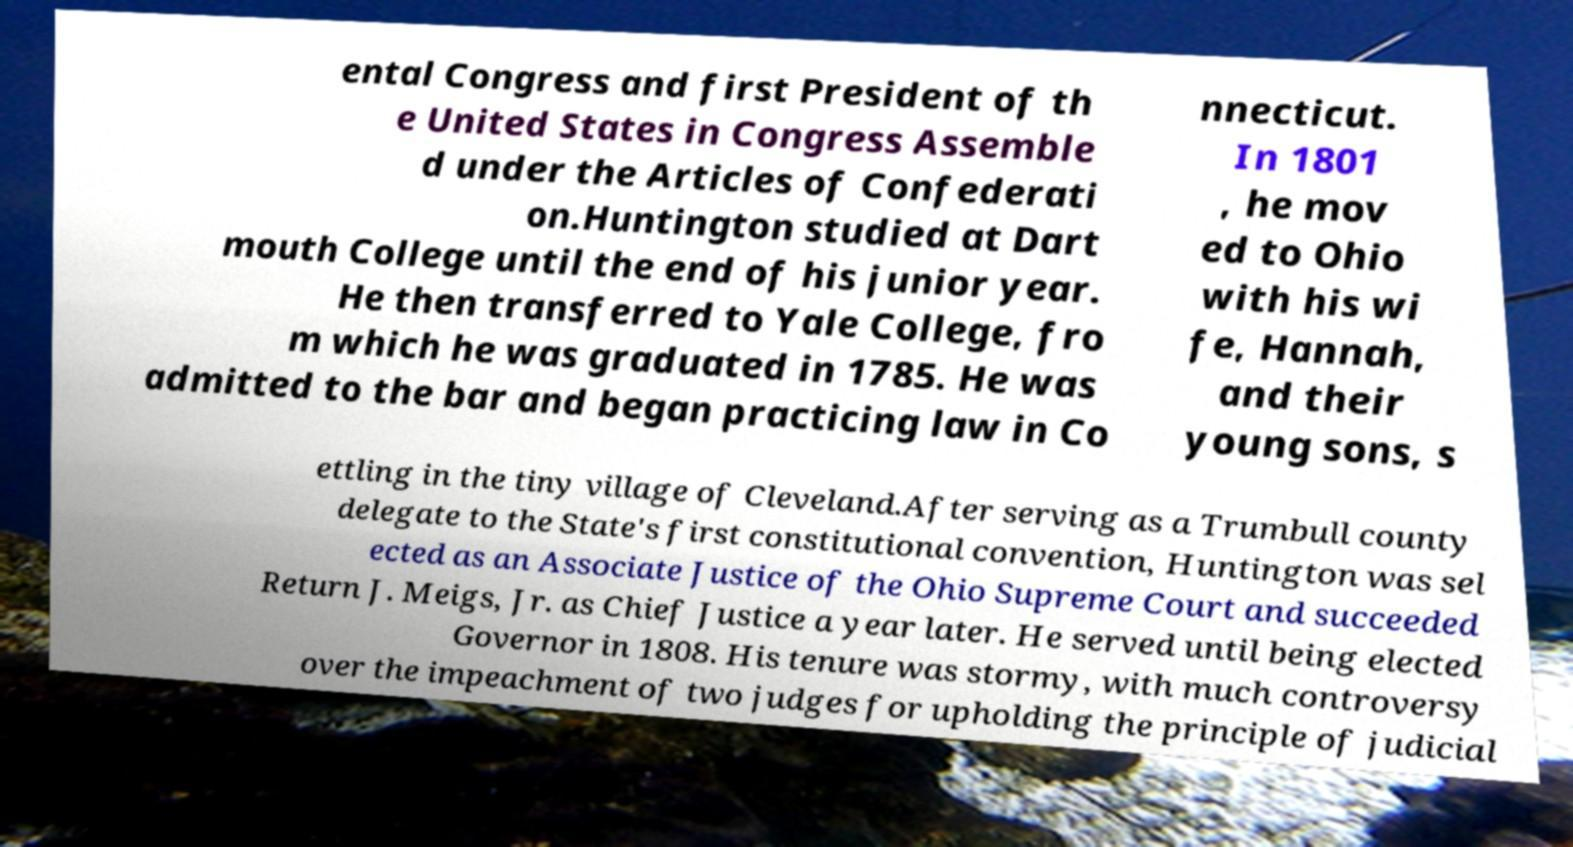Can you accurately transcribe the text from the provided image for me? ental Congress and first President of th e United States in Congress Assemble d under the Articles of Confederati on.Huntington studied at Dart mouth College until the end of his junior year. He then transferred to Yale College, fro m which he was graduated in 1785. He was admitted to the bar and began practicing law in Co nnecticut. In 1801 , he mov ed to Ohio with his wi fe, Hannah, and their young sons, s ettling in the tiny village of Cleveland.After serving as a Trumbull county delegate to the State's first constitutional convention, Huntington was sel ected as an Associate Justice of the Ohio Supreme Court and succeeded Return J. Meigs, Jr. as Chief Justice a year later. He served until being elected Governor in 1808. His tenure was stormy, with much controversy over the impeachment of two judges for upholding the principle of judicial 